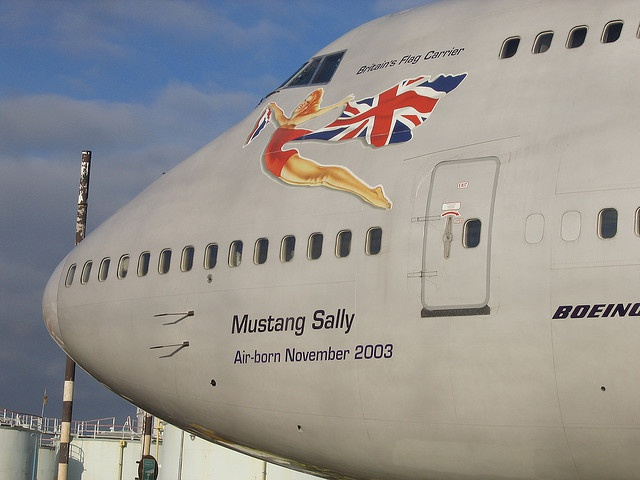Describe the objects in this image and their specific colors. I can see a airplane in darkgray and gray tones in this image. 